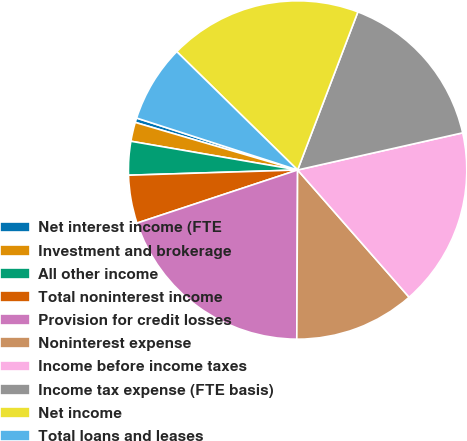<chart> <loc_0><loc_0><loc_500><loc_500><pie_chart><fcel>Net interest income (FTE<fcel>Investment and brokerage<fcel>All other income<fcel>Total noninterest income<fcel>Provision for credit losses<fcel>Noninterest expense<fcel>Income before income taxes<fcel>Income tax expense (FTE basis)<fcel>Net income<fcel>Total loans and leases<nl><fcel>0.43%<fcel>1.82%<fcel>3.21%<fcel>4.59%<fcel>19.84%<fcel>11.53%<fcel>17.07%<fcel>15.68%<fcel>18.46%<fcel>7.37%<nl></chart> 